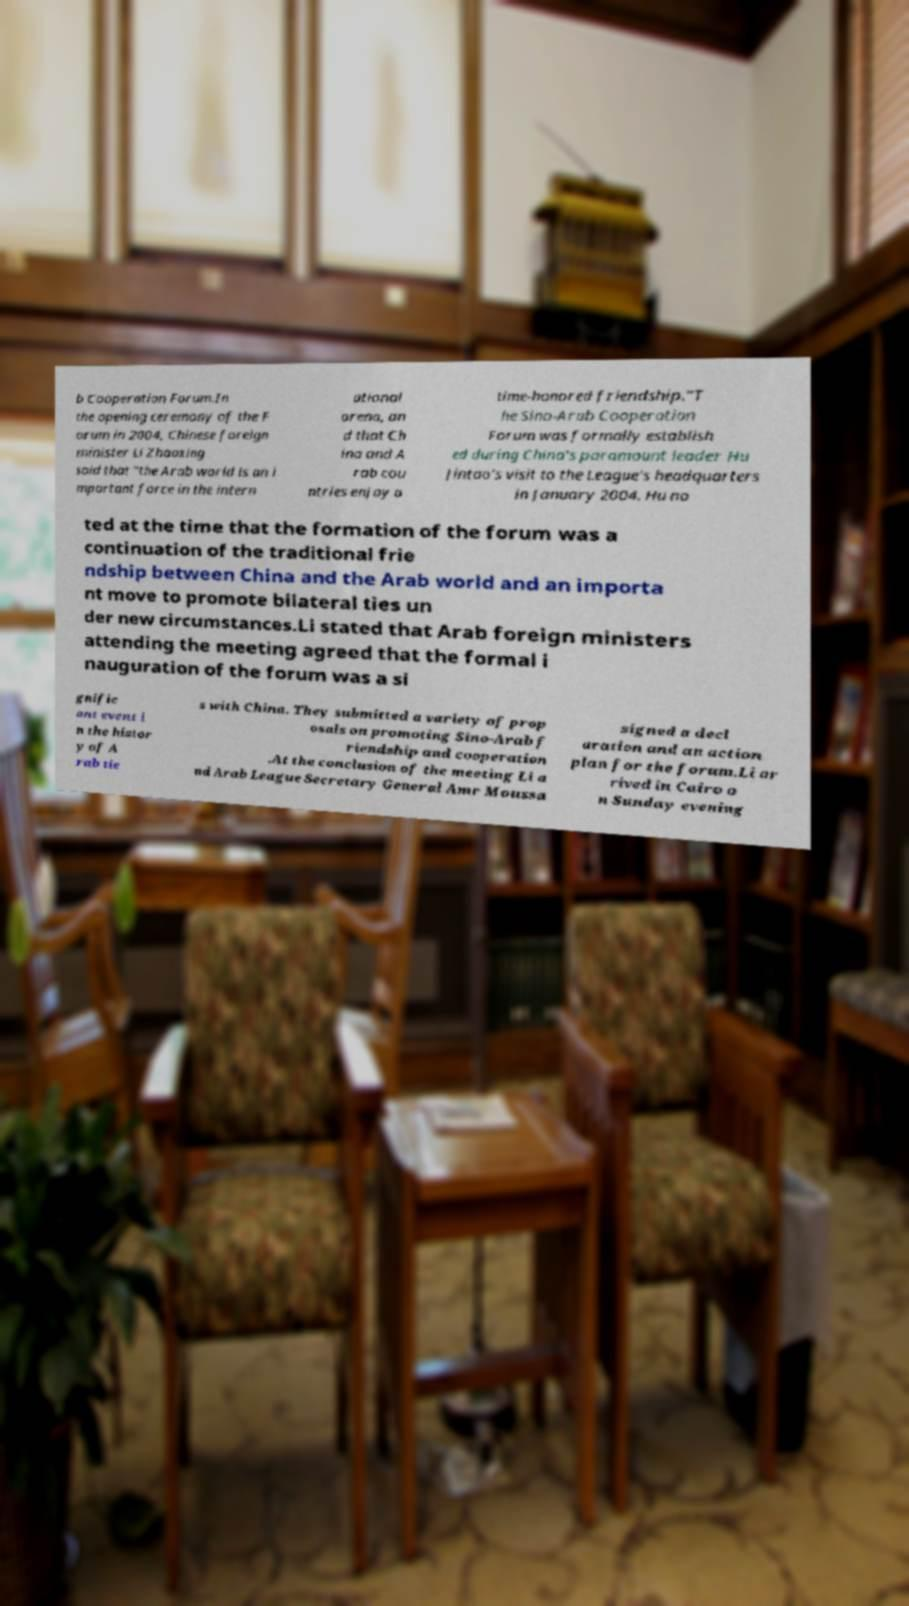For documentation purposes, I need the text within this image transcribed. Could you provide that? b Cooperation Forum.In the opening ceremony of the F orum in 2004, Chinese foreign minister Li Zhaoxing said that "the Arab world is an i mportant force in the intern ational arena, an d that Ch ina and A rab cou ntries enjoy a time-honored friendship."T he Sino-Arab Cooperation Forum was formally establish ed during China's paramount leader Hu Jintao's visit to the League's headquarters in January 2004. Hu no ted at the time that the formation of the forum was a continuation of the traditional frie ndship between China and the Arab world and an importa nt move to promote bilateral ties un der new circumstances.Li stated that Arab foreign ministers attending the meeting agreed that the formal i nauguration of the forum was a si gnific ant event i n the histor y of A rab tie s with China. They submitted a variety of prop osals on promoting Sino-Arab f riendship and cooperation .At the conclusion of the meeting Li a nd Arab League Secretary General Amr Moussa signed a decl aration and an action plan for the forum.Li ar rived in Cairo o n Sunday evening 